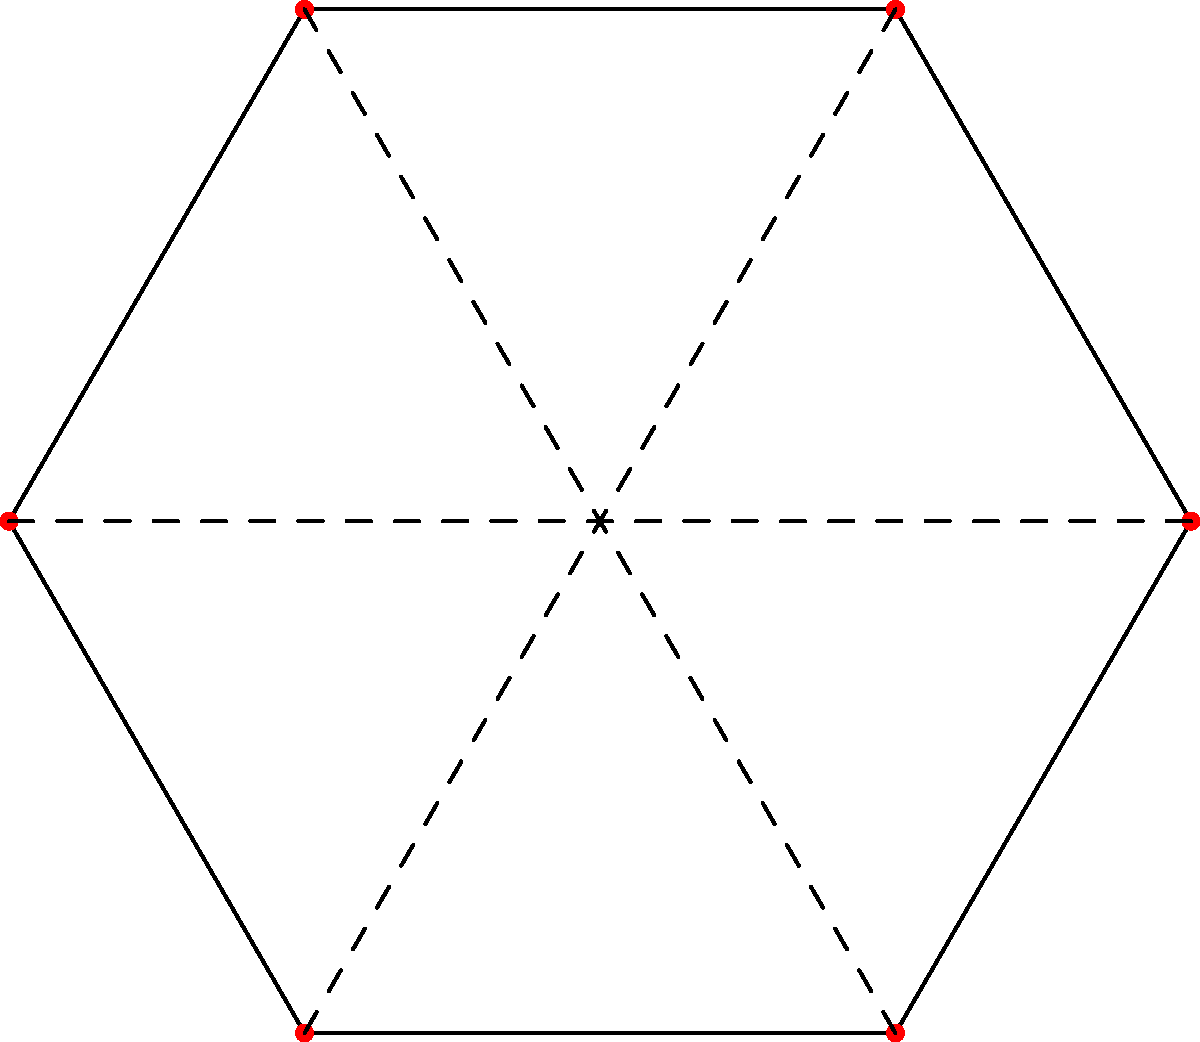In a production of "A Midsummer Night's Dream," the stage designer has created a hexagonal set with six symmetrically placed props. How many rotational symmetries does this stage design have, excluding the identity transformation? To determine the number of rotational symmetries in this hexagonal stage design, let's follow these steps:

1) First, recall that a regular hexagon has 6-fold rotational symmetry.

2) The rotational symmetries of a regular hexagon are:
   - 60° rotation (1/6 of a full turn)
   - 120° rotation (1/3 of a full turn)
   - 180° rotation (1/2 of a full turn)
   - 240° rotation (2/3 of a full turn)
   - 300° rotation (5/6 of a full turn)

3) Each of these rotations will map the hexagon and the symmetrically placed props onto themselves.

4) The identity transformation (0° or 360° rotation) is also a symmetry, but it's excluded as per the question.

5) Therefore, we count 5 distinct rotational symmetries.

This design choice not only creates a visually balanced set but also allows for interesting staging possibilities, as actors can utilize the symmetry in their movements and positioning.
Answer: 5 